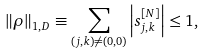<formula> <loc_0><loc_0><loc_500><loc_500>\left \| \rho \right \| _ { 1 , D } \equiv \sum _ { \left ( j , k \right ) \neq \left ( 0 , 0 \right ) } \left | s _ { j , k } ^ { \left [ N \right ] } \right | \leq 1 ,</formula> 